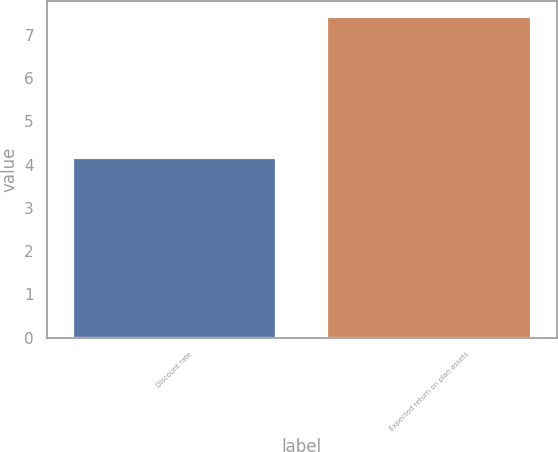<chart> <loc_0><loc_0><loc_500><loc_500><bar_chart><fcel>Discount rate<fcel>Expected return on plan assets<nl><fcel>4.16<fcel>7.41<nl></chart> 